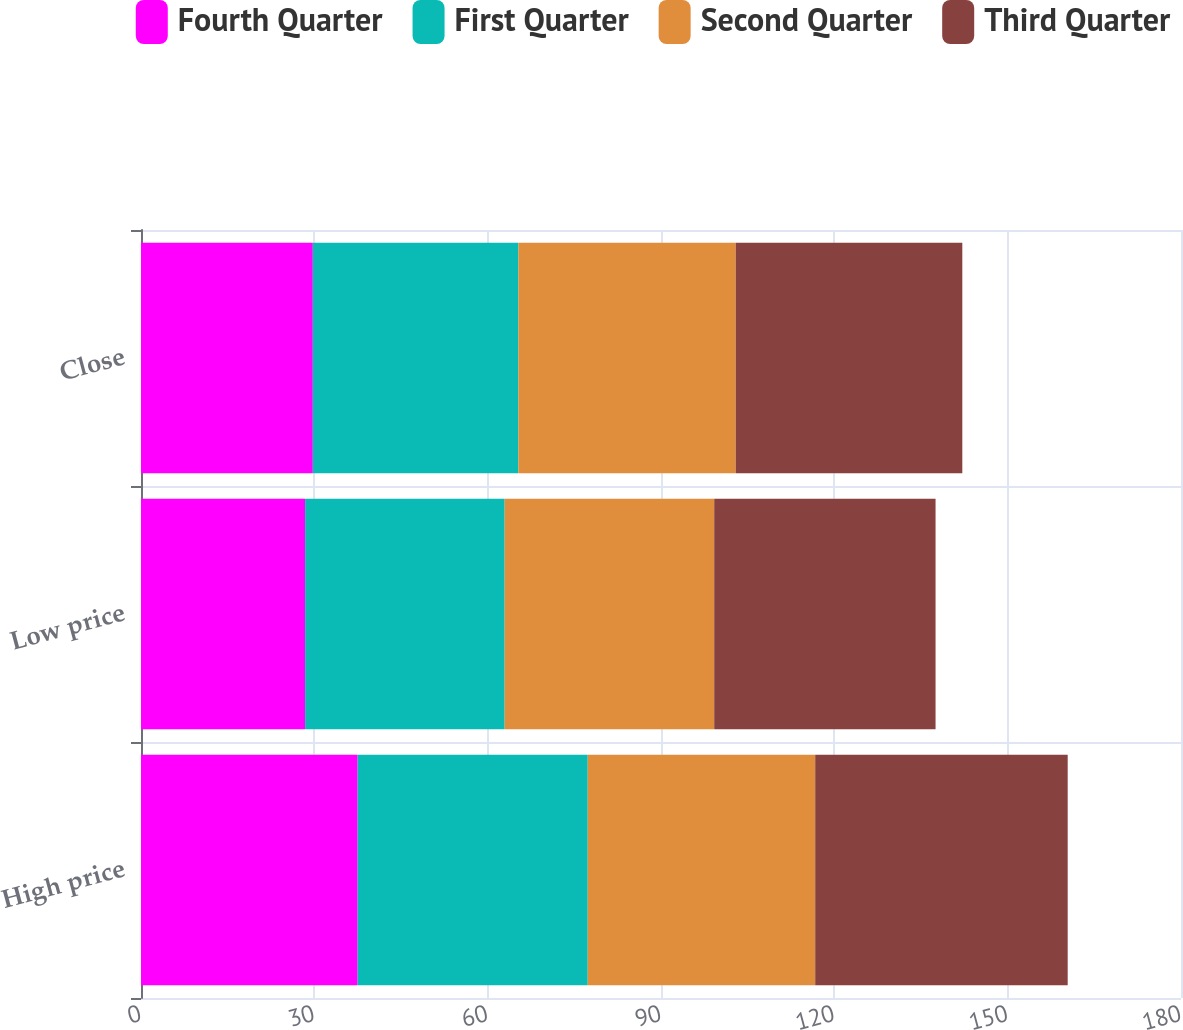Convert chart. <chart><loc_0><loc_0><loc_500><loc_500><stacked_bar_chart><ecel><fcel>High price<fcel>Low price<fcel>Close<nl><fcel>Fourth Quarter<fcel>37.5<fcel>28.4<fcel>29.74<nl><fcel>First Quarter<fcel>39.82<fcel>34.54<fcel>35.58<nl><fcel>Second Quarter<fcel>39.37<fcel>36.27<fcel>37.62<nl><fcel>Third Quarter<fcel>43.7<fcel>38.31<fcel>39.21<nl></chart> 